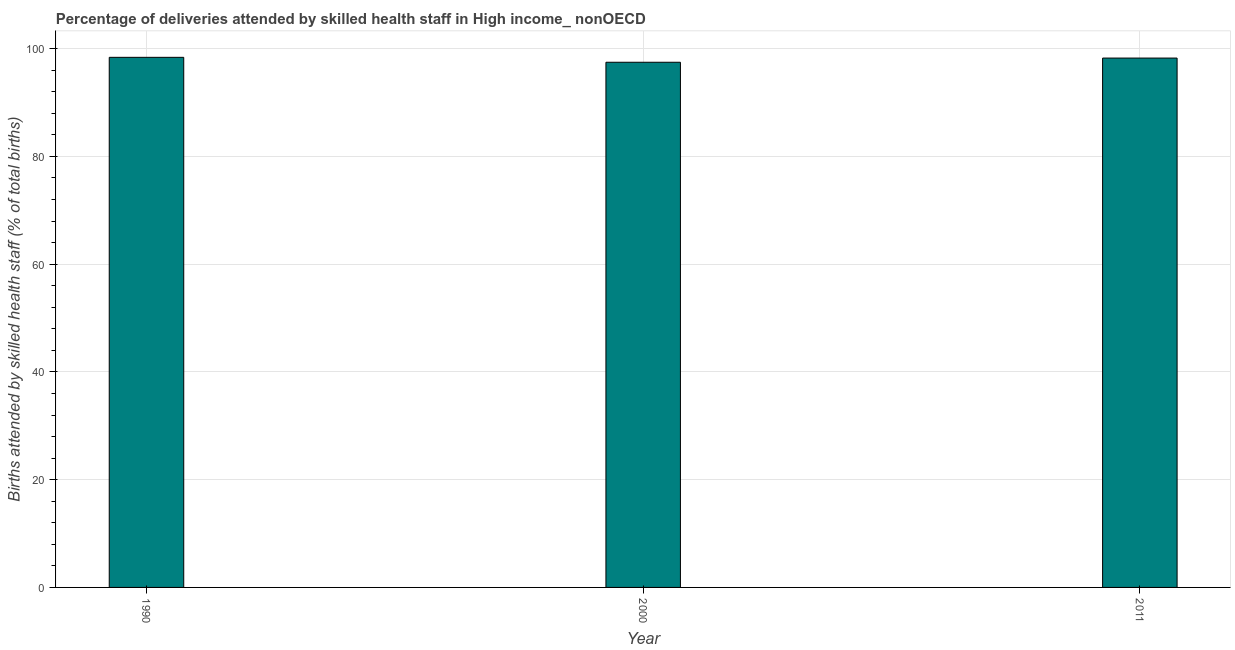What is the title of the graph?
Make the answer very short. Percentage of deliveries attended by skilled health staff in High income_ nonOECD. What is the label or title of the Y-axis?
Offer a very short reply. Births attended by skilled health staff (% of total births). What is the number of births attended by skilled health staff in 2000?
Ensure brevity in your answer.  97.48. Across all years, what is the maximum number of births attended by skilled health staff?
Ensure brevity in your answer.  98.39. Across all years, what is the minimum number of births attended by skilled health staff?
Make the answer very short. 97.48. In which year was the number of births attended by skilled health staff maximum?
Offer a very short reply. 1990. What is the sum of the number of births attended by skilled health staff?
Ensure brevity in your answer.  294.12. What is the difference between the number of births attended by skilled health staff in 2000 and 2011?
Your answer should be very brief. -0.78. What is the average number of births attended by skilled health staff per year?
Provide a short and direct response. 98.04. What is the median number of births attended by skilled health staff?
Your answer should be compact. 98.25. In how many years, is the number of births attended by skilled health staff greater than 68 %?
Your answer should be compact. 3. What is the ratio of the number of births attended by skilled health staff in 1990 to that in 2011?
Offer a terse response. 1. Is the number of births attended by skilled health staff in 1990 less than that in 2011?
Give a very brief answer. No. What is the difference between the highest and the second highest number of births attended by skilled health staff?
Keep it short and to the point. 0.14. Is the sum of the number of births attended by skilled health staff in 2000 and 2011 greater than the maximum number of births attended by skilled health staff across all years?
Make the answer very short. Yes. What is the difference between the highest and the lowest number of births attended by skilled health staff?
Ensure brevity in your answer.  0.91. What is the difference between two consecutive major ticks on the Y-axis?
Your answer should be very brief. 20. Are the values on the major ticks of Y-axis written in scientific E-notation?
Keep it short and to the point. No. What is the Births attended by skilled health staff (% of total births) in 1990?
Offer a very short reply. 98.39. What is the Births attended by skilled health staff (% of total births) of 2000?
Give a very brief answer. 97.48. What is the Births attended by skilled health staff (% of total births) in 2011?
Keep it short and to the point. 98.25. What is the difference between the Births attended by skilled health staff (% of total births) in 1990 and 2000?
Offer a terse response. 0.91. What is the difference between the Births attended by skilled health staff (% of total births) in 1990 and 2011?
Keep it short and to the point. 0.14. What is the difference between the Births attended by skilled health staff (% of total births) in 2000 and 2011?
Ensure brevity in your answer.  -0.78. What is the ratio of the Births attended by skilled health staff (% of total births) in 1990 to that in 2000?
Offer a very short reply. 1.01. What is the ratio of the Births attended by skilled health staff (% of total births) in 1990 to that in 2011?
Your answer should be very brief. 1. What is the ratio of the Births attended by skilled health staff (% of total births) in 2000 to that in 2011?
Make the answer very short. 0.99. 